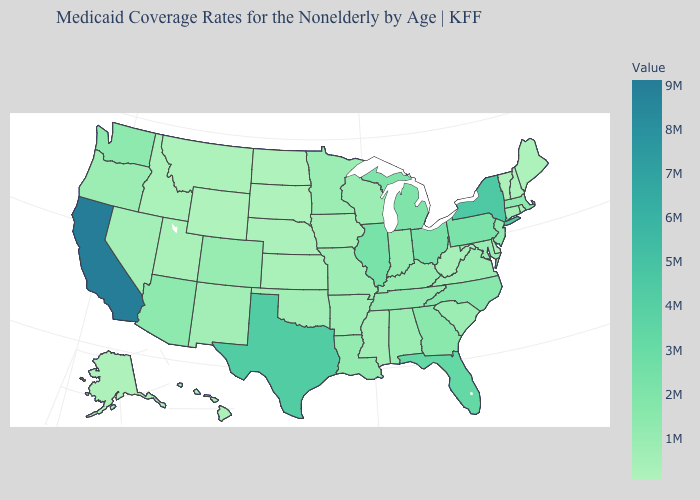Does the map have missing data?
Short answer required. No. Does Vermont have the lowest value in the Northeast?
Keep it brief. Yes. Does West Virginia have a higher value than Michigan?
Answer briefly. No. Does Texas have the highest value in the South?
Short answer required. Yes. Is the legend a continuous bar?
Concise answer only. Yes. 